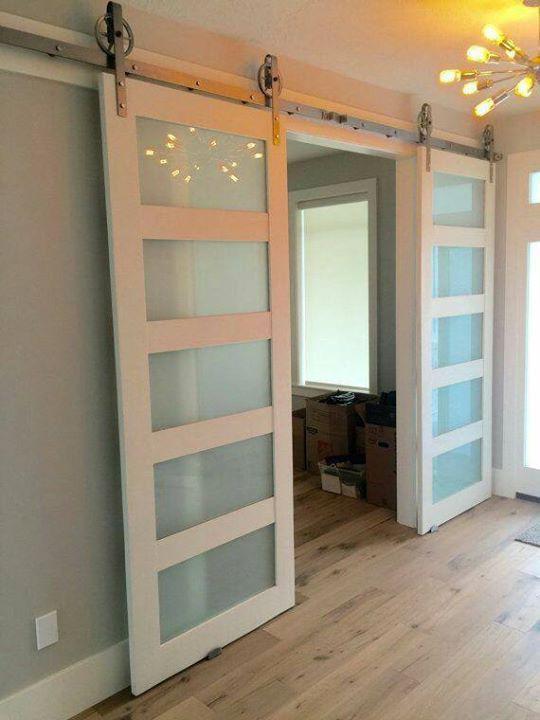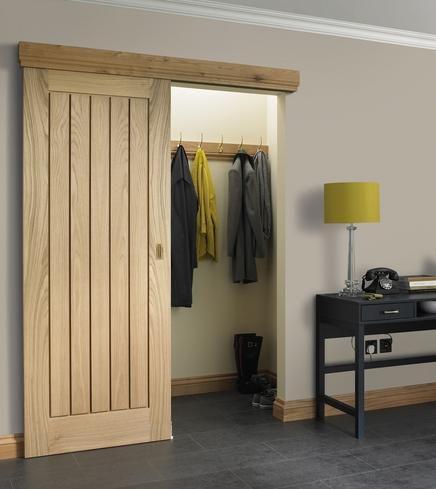The first image is the image on the left, the second image is the image on the right. Examine the images to the left and right. Is the description "One door is solid wood." accurate? Answer yes or no. Yes. The first image is the image on the left, the second image is the image on the right. Analyze the images presented: Is the assertion "In at least one image there is a single hanging door on a track." valid? Answer yes or no. Yes. 